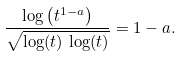<formula> <loc_0><loc_0><loc_500><loc_500>\frac { \log \left ( t ^ { 1 - a } \right ) } { \sqrt { \log ( t ) \, \log ( t ) } } = 1 - a .</formula> 